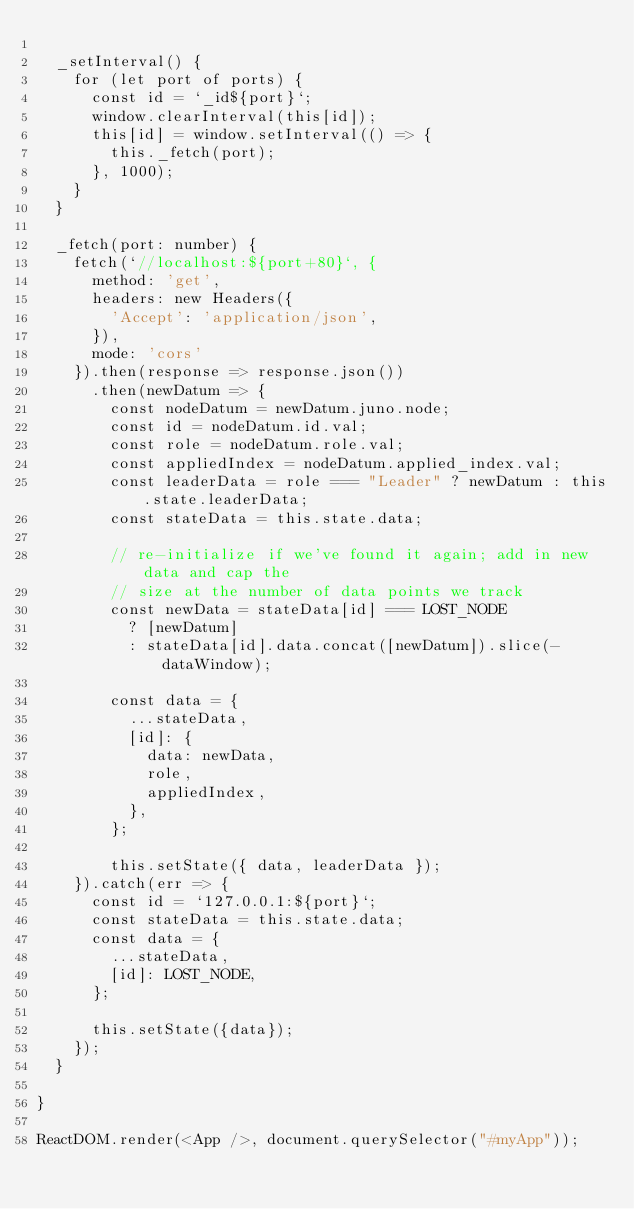<code> <loc_0><loc_0><loc_500><loc_500><_JavaScript_>
  _setInterval() {
    for (let port of ports) {
      const id = `_id${port}`;
      window.clearInterval(this[id]);
      this[id] = window.setInterval(() => {
        this._fetch(port);
      }, 1000);
    }
  }

  _fetch(port: number) {
    fetch(`//localhost:${port+80}`, {
      method: 'get',
      headers: new Headers({
        'Accept': 'application/json',
      }),
      mode: 'cors'
    }).then(response => response.json())
      .then(newDatum => {
        const nodeDatum = newDatum.juno.node;
        const id = nodeDatum.id.val;
        const role = nodeDatum.role.val;
        const appliedIndex = nodeDatum.applied_index.val;
        const leaderData = role === "Leader" ? newDatum : this.state.leaderData;
        const stateData = this.state.data;

        // re-initialize if we've found it again; add in new data and cap the
        // size at the number of data points we track
        const newData = stateData[id] === LOST_NODE
          ? [newDatum]
          : stateData[id].data.concat([newDatum]).slice(-dataWindow);

        const data = {
          ...stateData,
          [id]: {
            data: newData,
            role,
            appliedIndex,
          },
        };

        this.setState({ data, leaderData });
    }).catch(err => {
      const id = `127.0.0.1:${port}`;
      const stateData = this.state.data;
      const data = {
        ...stateData,
        [id]: LOST_NODE,
      };

      this.setState({data});
    });
  }

}

ReactDOM.render(<App />, document.querySelector("#myApp"));
</code> 